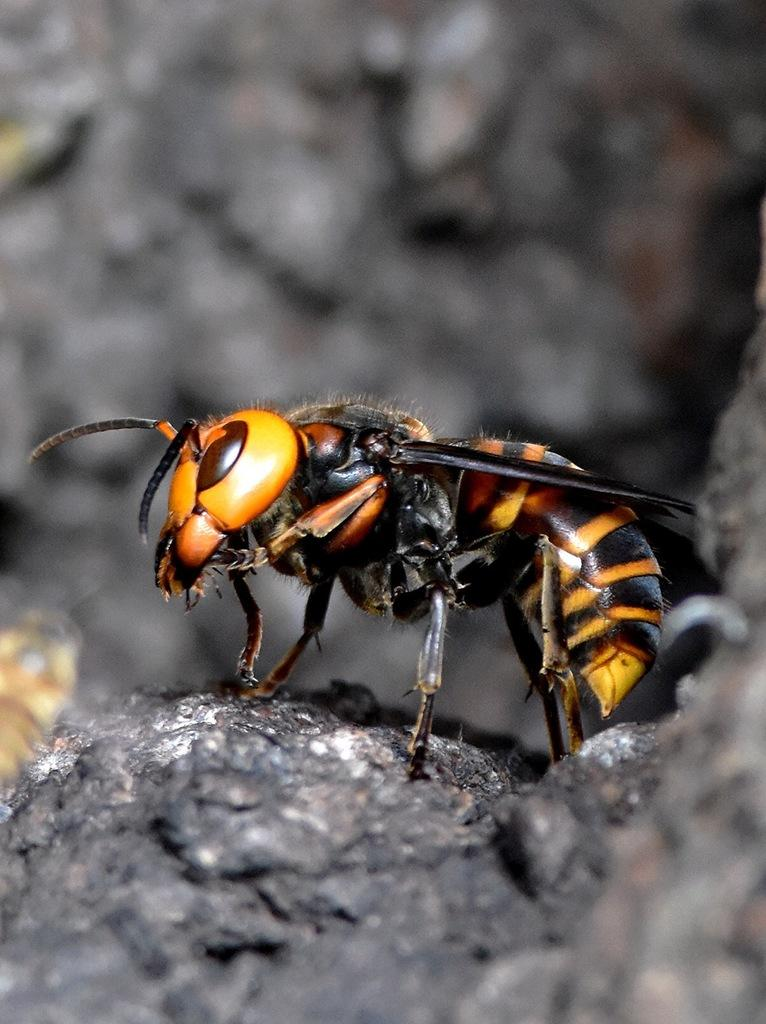What type of creature is in the image? There is an insect in the image. Where is the insect located? The insect is on a rock. What type of ornament is hanging from the cactus in the image? There is no cactus or ornament present in the image; it features an insect on a rock. 